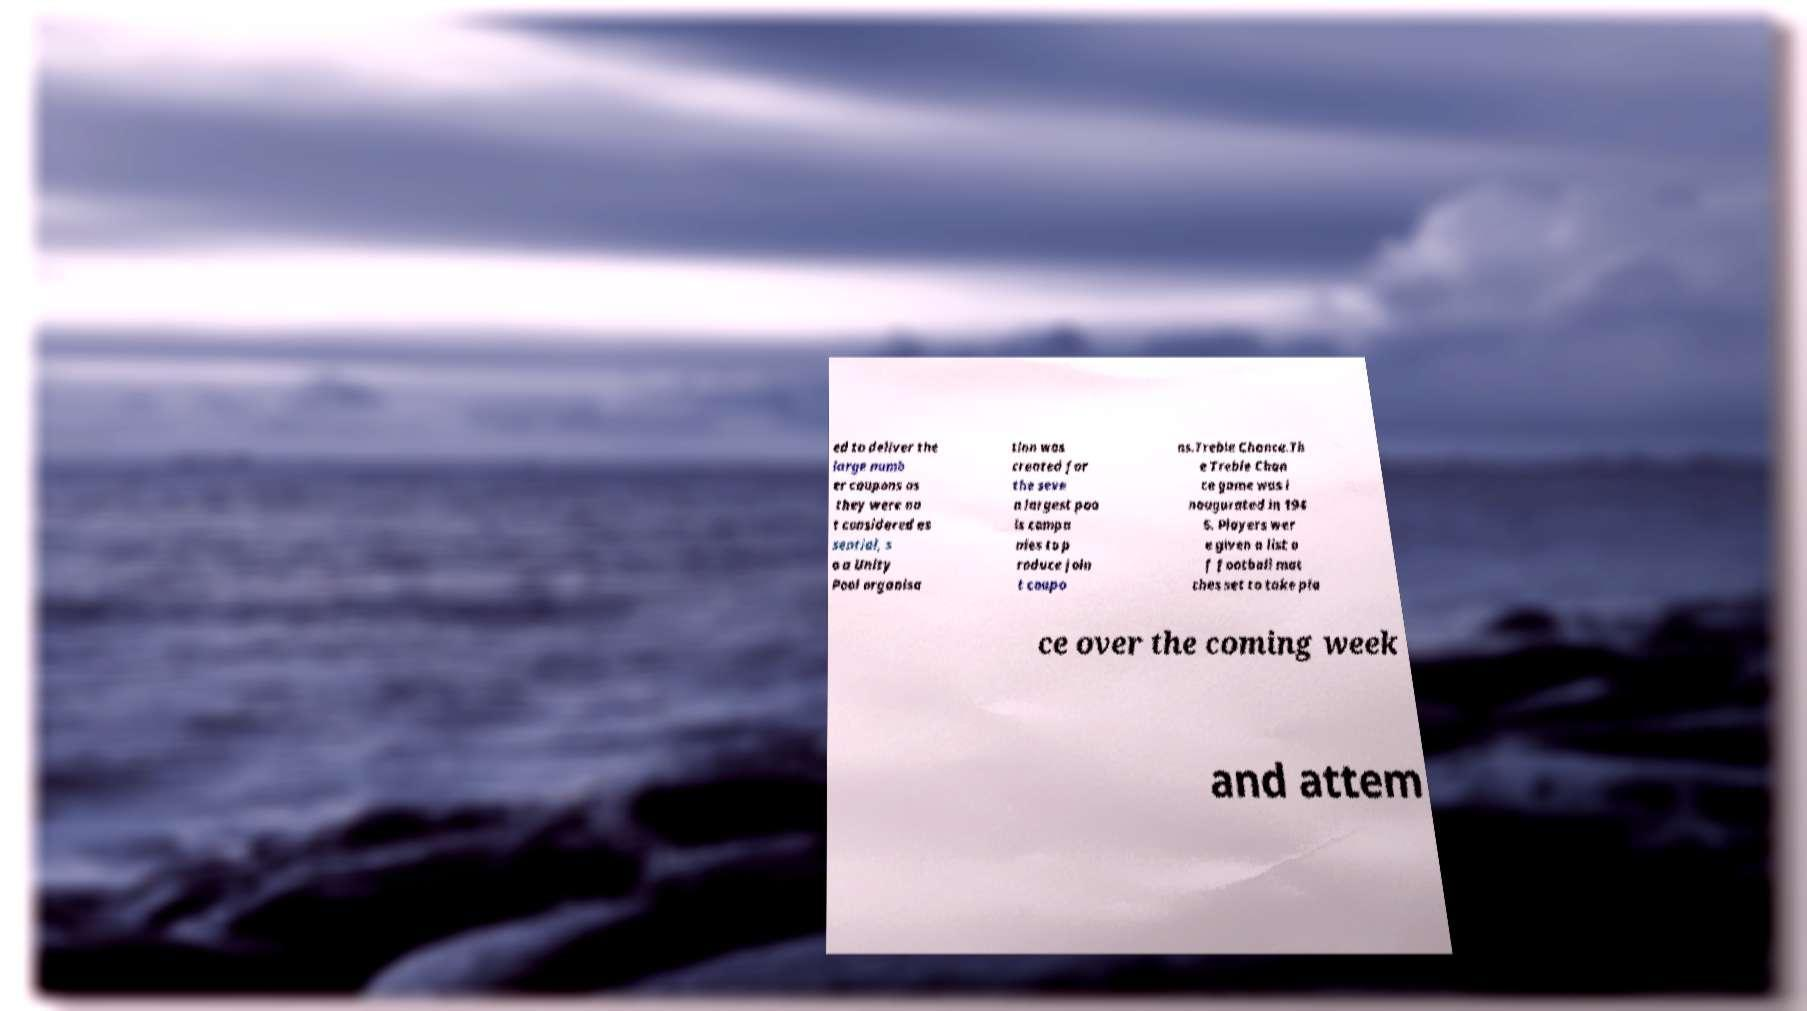For documentation purposes, I need the text within this image transcribed. Could you provide that? ed to deliver the large numb er coupons as they were no t considered es sential, s o a Unity Pool organisa tion was created for the seve n largest poo ls compa nies to p roduce join t coupo ns.Treble Chance.Th e Treble Chan ce game was i naugurated in 194 6. Players wer e given a list o f football mat ches set to take pla ce over the coming week and attem 